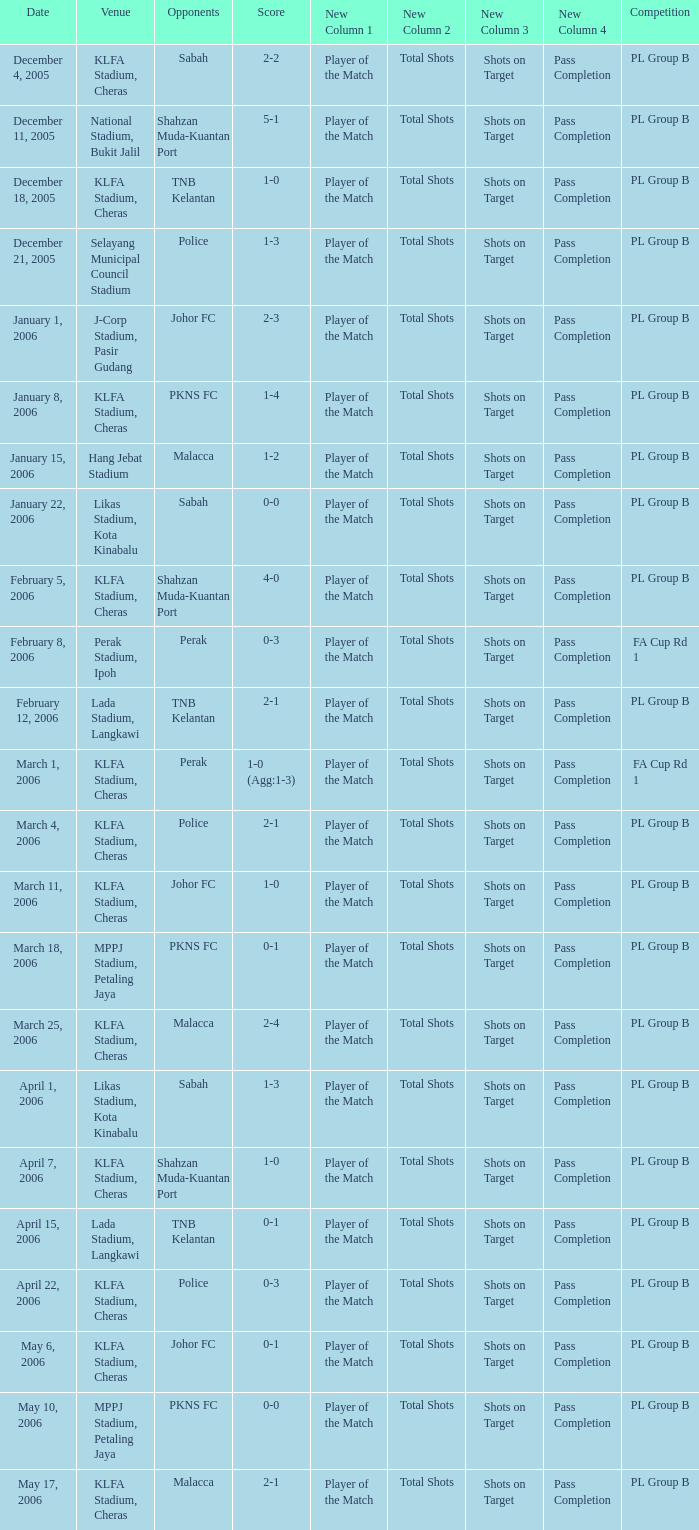Which Score has Opponents of pkns fc, and a Date of january 8, 2006? 1-4. 